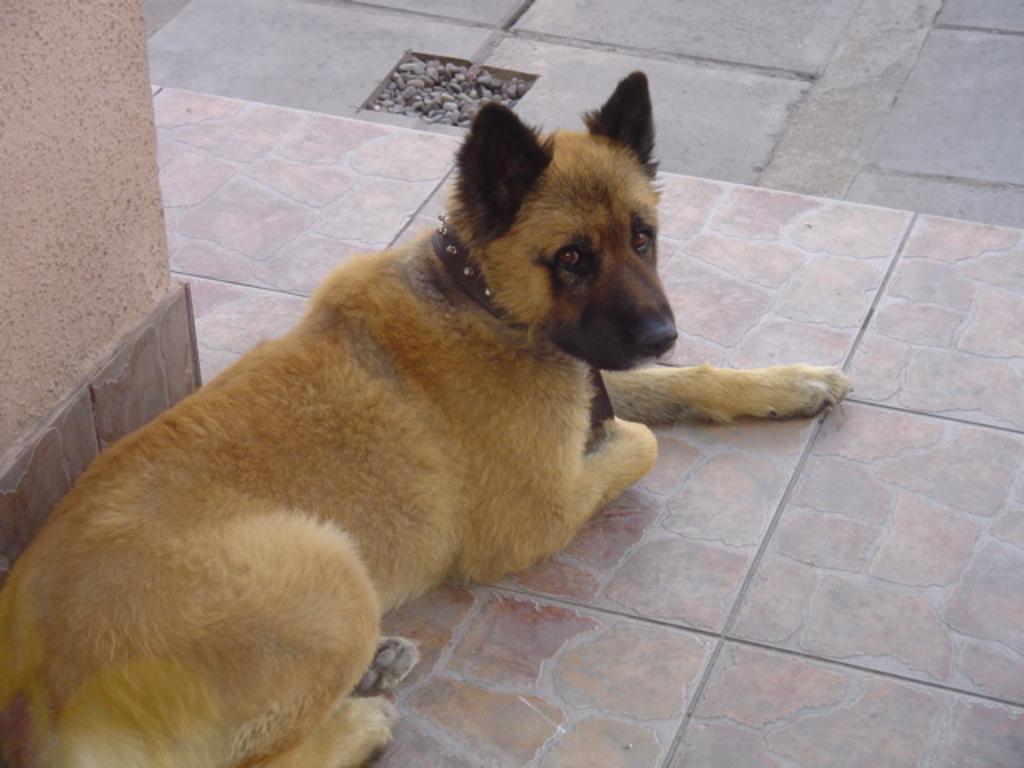Please provide a concise description of this image. In this image in the center there is one dog, and at the bottom there is floor and on the left side there is one pillar. 